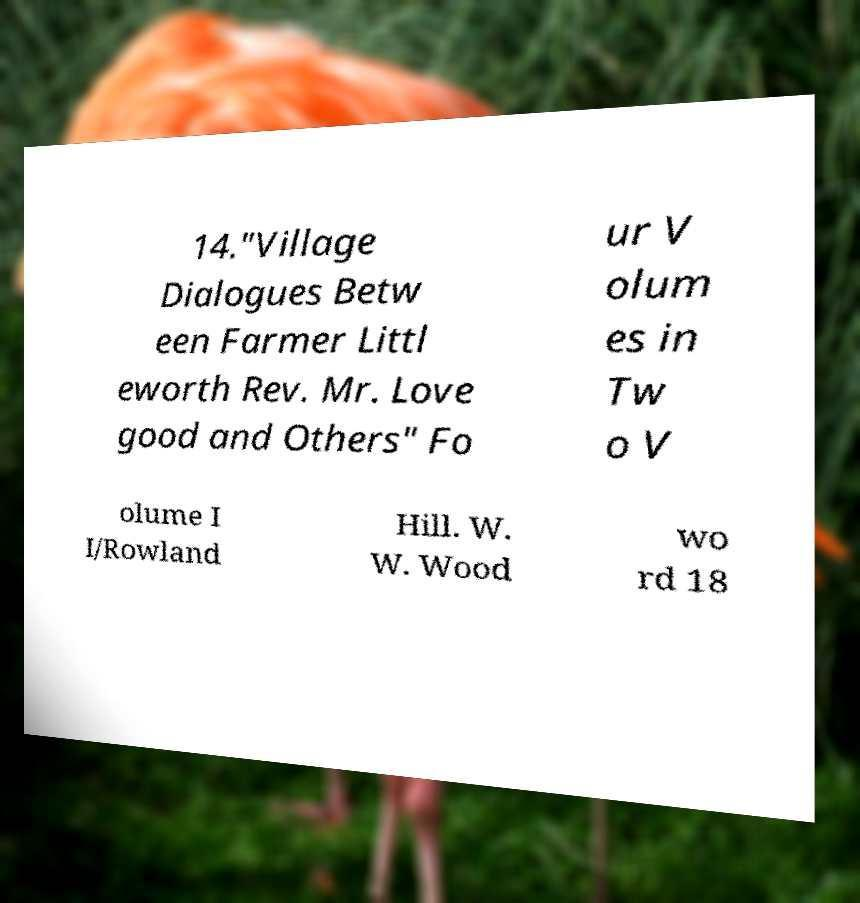Please identify and transcribe the text found in this image. 14."Village Dialogues Betw een Farmer Littl eworth Rev. Mr. Love good and Others" Fo ur V olum es in Tw o V olume I I/Rowland Hill. W. W. Wood wo rd 18 